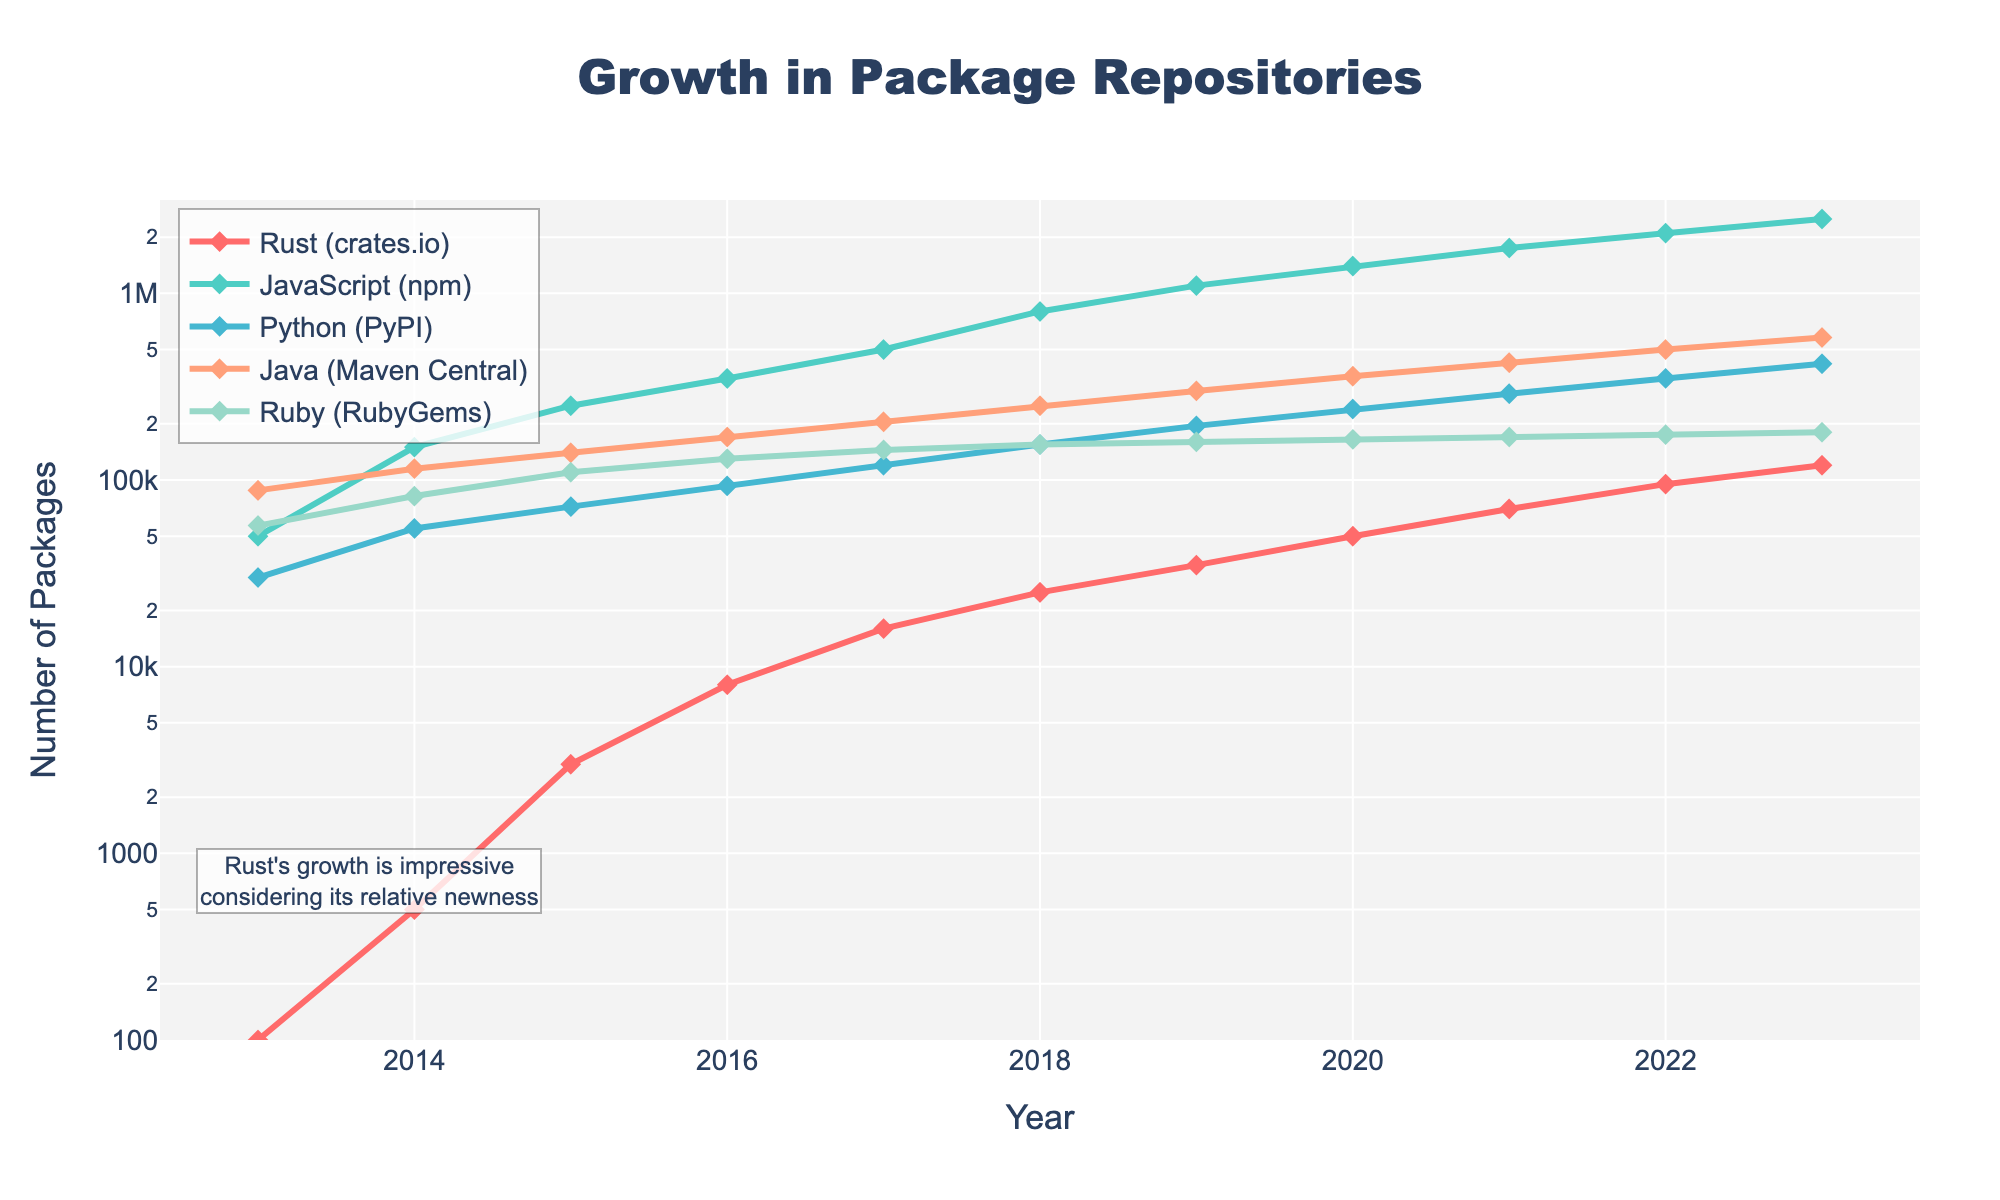What year did Rust's package repository surpass 50,000 packages? First, locate the Rust (crates.io) line. Then, identify the year when the number of packages crosses the 50,000 mark. In the figure, this milestone is achieved in 2020.
Answer: 2020 How many more packages were on PyPI than on crates.io in 2023? Find the data points for Python (PyPI) and Rust (crates.io) for the year 2023. The respective values are 420,000 and 120,000. Subtract the number of crates.io packages from PyPI packages: 420,000 - 120,000 = 300,000.
Answer: 300,000 Which language had the steepest growth from 2016 to 2022? Inspect the slopes of the lines for each language between 2016 and 2022. JavaScript (npm) shows the steepest increase, growing from 350,000 to 2,100,000 packages. No other language saw such a drastic increase during this period.
Answer: JavaScript In what year did Java (Maven Central) reach 250,000 packages? Locate the Java line (Maven Central) and find the data point where it first reaches 250,000 packages. According to the figure, this point is in 2018.
Answer: 2018 What is the ratio of Rust (crates.io) packages to Ruby (RubyGems) packages in 2021? Find the number of Rust and Ruby packages for 2021 from the chart, which are 70,000 and 170,000, respectively. The ratio is calculated as 70,000 / 170,000, which simplifies to approximately 0.41.
Answer: 0.41 Which language had the smallest growth between 2019 and 2023? Compare the growth of all the languages from 2019 to 2023. Ruby (RubyGems) grew from 160,000 to 180,000 packages, which is a growth of 20,000. This is the smallest increase among the languages shown.
Answer: Ruby Between 2014 and 2018, which language had the highest average annual growth rate? Calculate the annual growth rates for each language between 2014 and 2018 and then find the average for each. JavaScript (npm) has the highest growth rate, growing from 150,000 to 800,000, for an average of 162,500 per year (650,000/4).
Answer: JavaScript By what factor did the number of Rust packages increase from 2013 to 2023? Find the number of Rust packages in 2013 and 2023, which are 100 and 120,000 respectively. The factor increase is calculated as 120,000 / 100 = 1,200.
Answer: 1,200 What was the first year in which JavaScript (npm) had more than 1 million packages? Locate the JavaScript line and identify the first data point where it crossed 1,000,000 packages. According to the figure, this milestone was achieved in 2019.
Answer: 2019 Which language had a steady growth without any visible dips for the entire period from 2013 to 2023? Examine the trend lines for all languages over the entire period. Java (Maven Central) shows continuous, steady growth without any visible dips.
Answer: Java 